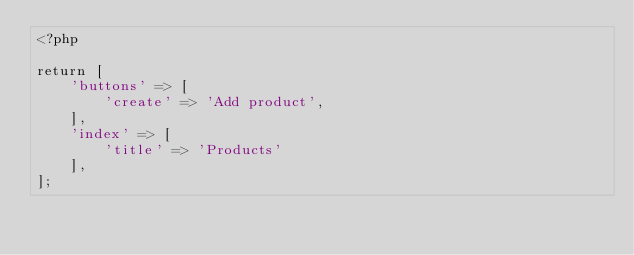Convert code to text. <code><loc_0><loc_0><loc_500><loc_500><_PHP_><?php

return [
    'buttons' => [
        'create' => 'Add product',
    ],
    'index' => [
        'title' => 'Products'
    ],
];
</code> 